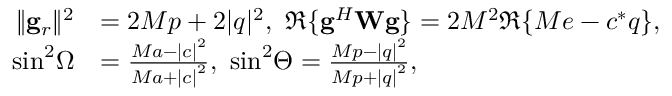Convert formula to latex. <formula><loc_0><loc_0><loc_500><loc_500>\begin{array} { r l } { { \| { { { g } _ { r } } } \| ^ { 2 } } } & { = 2 M p + 2 { | q | ^ { 2 } } , \Re \{ { { { g } ^ { H } } { W g } } \} = 2 M ^ { 2 } \Re \{ M e - c ^ { * } q \} , } \\ { { \sin ^ { 2 } } \Omega } & { = \frac { { M a - { { | c | } ^ { 2 } } } } { { M a + { { | c | } ^ { 2 } } } } , { \sin ^ { 2 } } \Theta = \frac { { M p - { { | q | } ^ { 2 } } } } { { M p + { { | q | } ^ { 2 } } } } , } \end{array}</formula> 